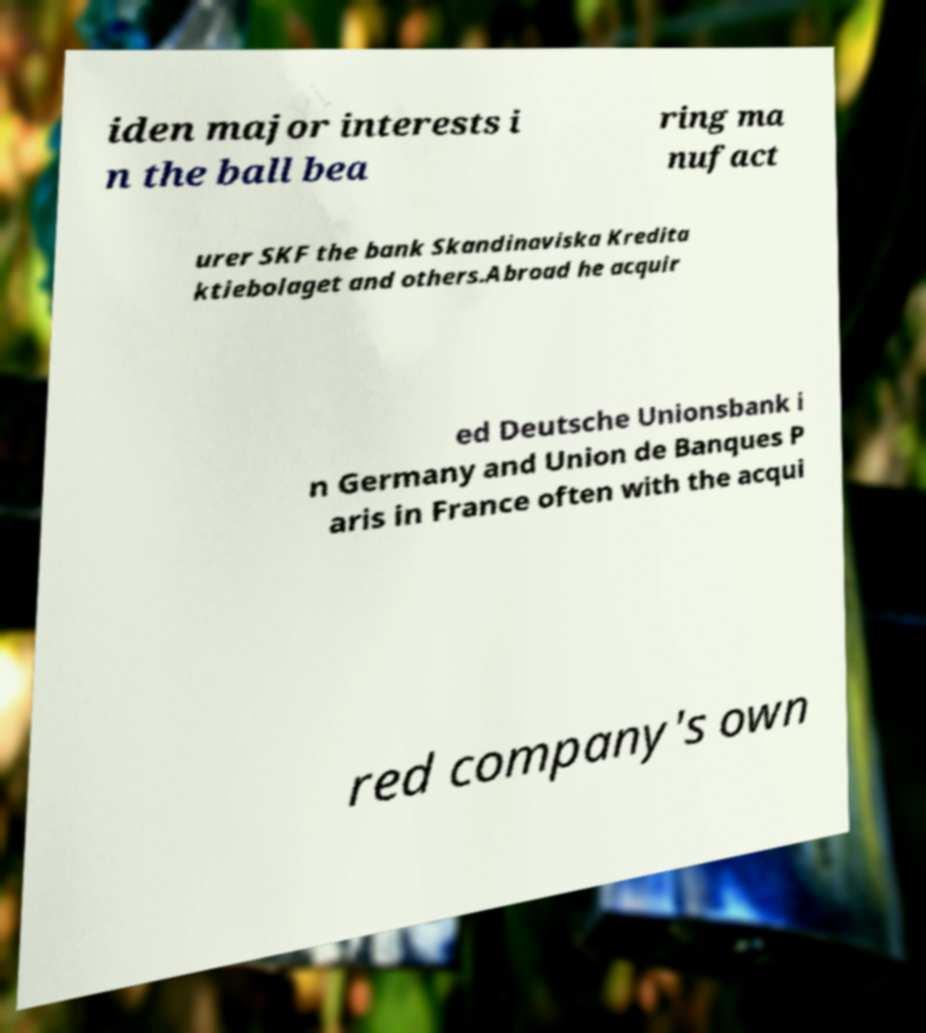Please read and relay the text visible in this image. What does it say? iden major interests i n the ball bea ring ma nufact urer SKF the bank Skandinaviska Kredita ktiebolaget and others.Abroad he acquir ed Deutsche Unionsbank i n Germany and Union de Banques P aris in France often with the acqui red company's own 